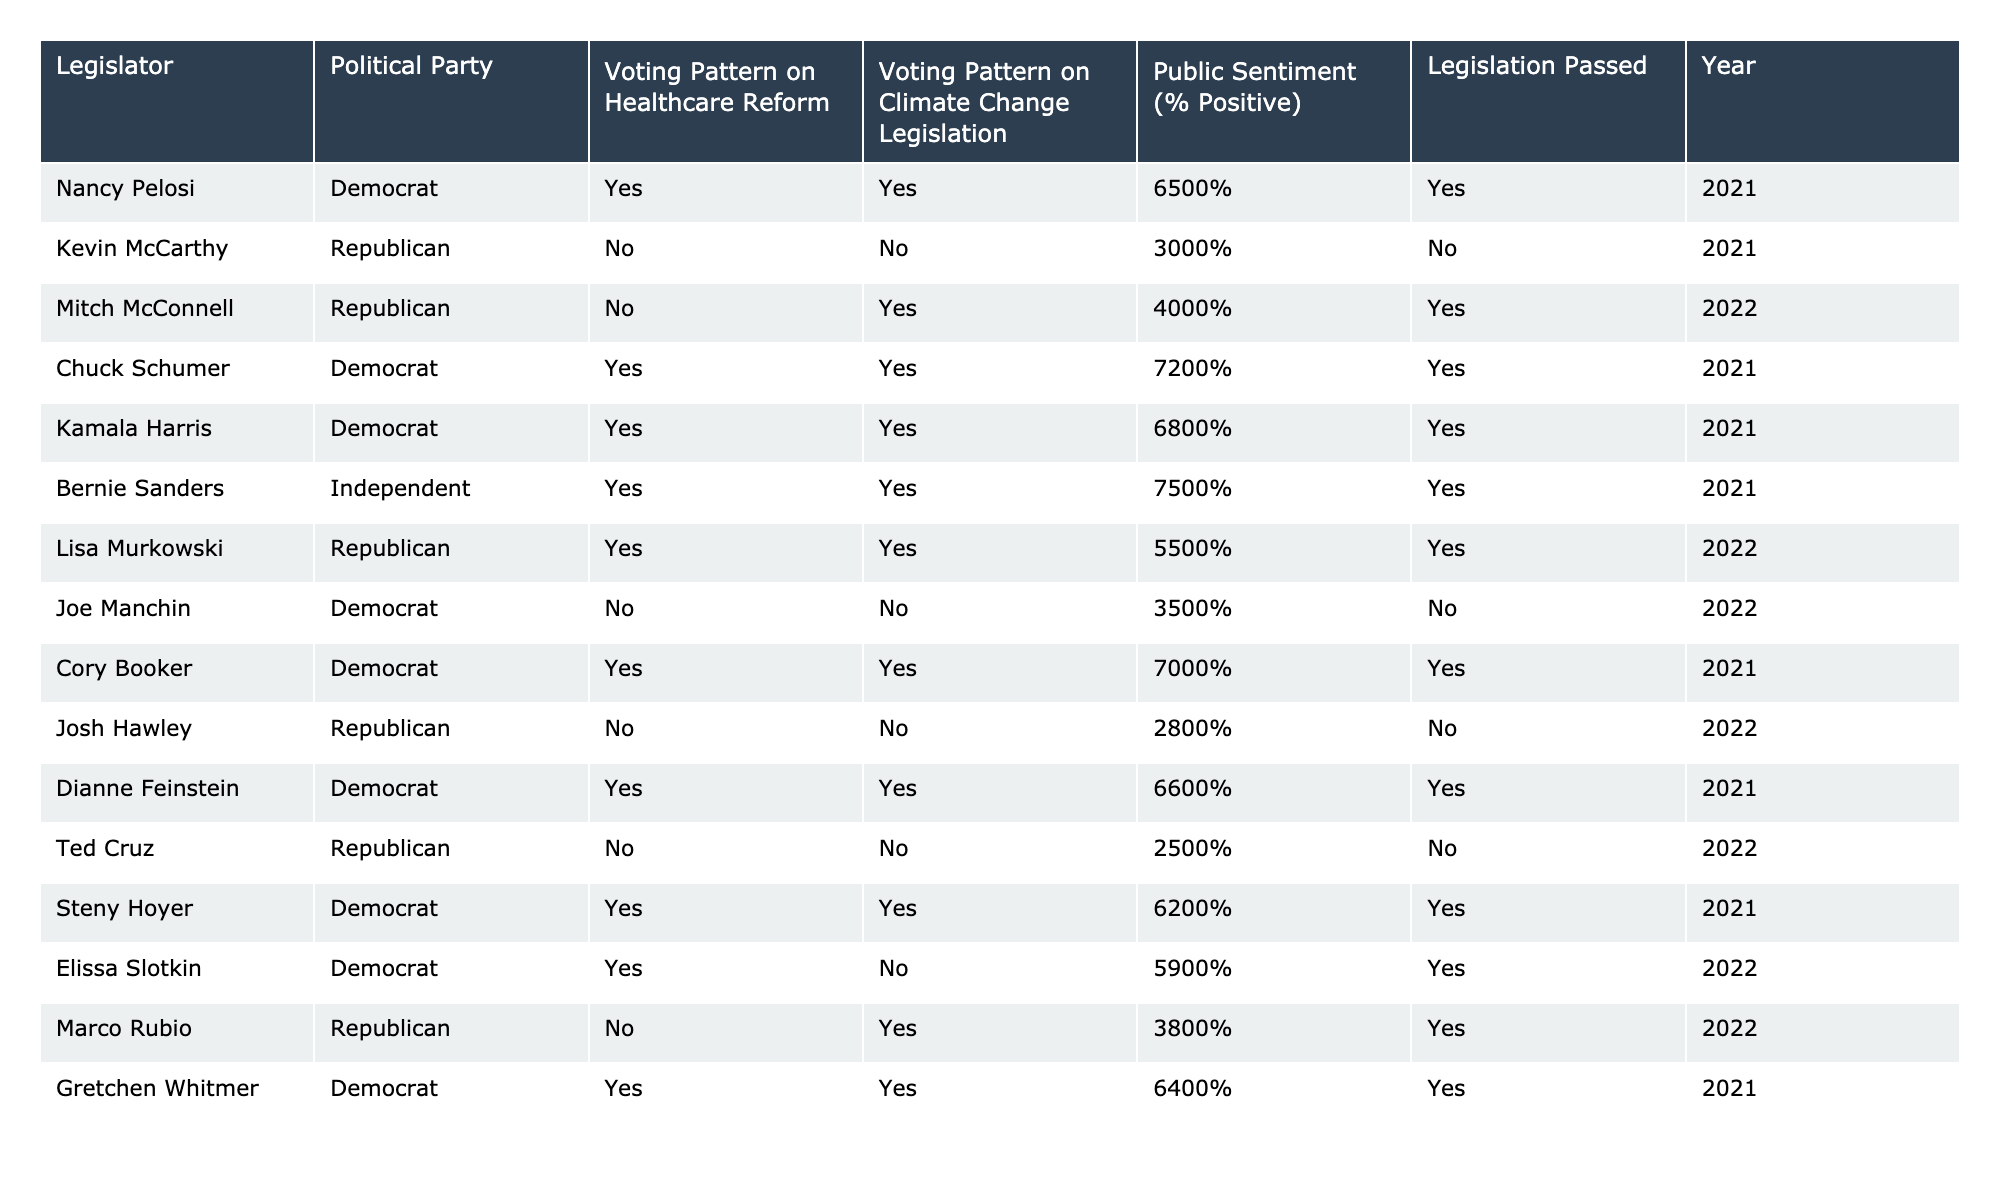What percentage of positive public sentiment did Bernie Sanders receive? The table shows that Bernie Sanders has a public sentiment of 75%, which is listed directly in the row corresponding to his name.
Answer: 75% Which legislator passed legislation but had a public sentiment below 60%? By examining the table, Joe Manchin is the only legislator who did not pass legislation while having a public sentiment of 35%, which is below 60%.
Answer: Joe Manchin How many Democrats received a positive public sentiment above 70%? The table highlights three Democrats—Chuck Schumer (72%), Kamala Harris (68%), and Cory Booker (70%)—but only Chuck Schumer and Bernie Sanders have sentiments above 70%. Therefore, there are two Democrats with sentiments above 70%.
Answer: 2 What is the average public sentiment for legislators who voted yes on healthcare reform? The total sentiment percentages for those who voted yes on healthcare reform are 65, 72, 68, 75, 70, 66, 62, 59, and 64, which sum to 536. There are 9 legislators, so the average is 536/9, which equals approximately 59.56%.
Answer: 59.56% Did any Republican legislator vote yes on both healthcare reform and climate change legislation? Reviewing the table, Lisa Murkowski is the only Republican legislator who voted yes on both healthcare reform and climate change legislation.
Answer: Yes What is the public sentiment difference between the highest and lowest among legislators who passed legislation? The highest public sentiment is 75% (Bernie Sanders) and the lowest is 30% (Kevin McCarthy). The difference is 75 - 30 = 45%.
Answer: 45% How many legislators had a negative public sentiment (< 50%) while voting against healthcare reform? The legislators voting against healthcare reform and having a negative sentiment are Kevin McCarthy (30%) and Josh Hawley (28%), totaling 2 legislators.
Answer: 2 Which political party has more representatives with positive public sentiment above 60%? The Democrats have eight representatives with sentiments above 60% while the Republicans have only one (Lisa Murkowski). Therefore, Democrats have more.
Answer: Democrats How many total pieces of legislation were passed by legislators with public sentiments of 60% or more? The legislators with sentiments of 60% or greater who passed legislation are Chuck Schumer, Kamala Harris, Bernie Sanders, Cory Booker, Dianne Feinstein, Steny Hoyer, and Gretchen Whitmer, totaling 7 pieces of passed legislation.
Answer: 7 Which legislator had a positive public sentiment below average compared to all other legislators? The average public sentiment across all legislators is approximately 55.5%. Joe Manchin (35%) and Kevin McCarthy (30%) had sentiments below this average. Identifying only one (the first alphabetically) leads to Joe Manchin.
Answer: Joe Manchin 